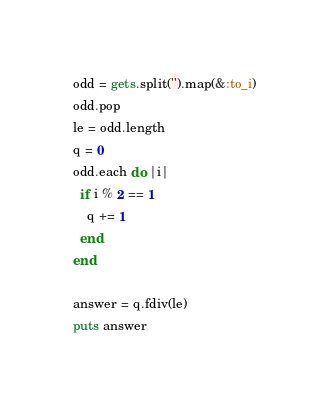Convert code to text. <code><loc_0><loc_0><loc_500><loc_500><_Ruby_>odd = gets.split('').map(&:to_i)
odd.pop
le = odd.length
q = 0
odd.each do |i|
  if i % 2 == 1
    q += 1
  end
end

answer = q.fdiv(le)
puts answer</code> 